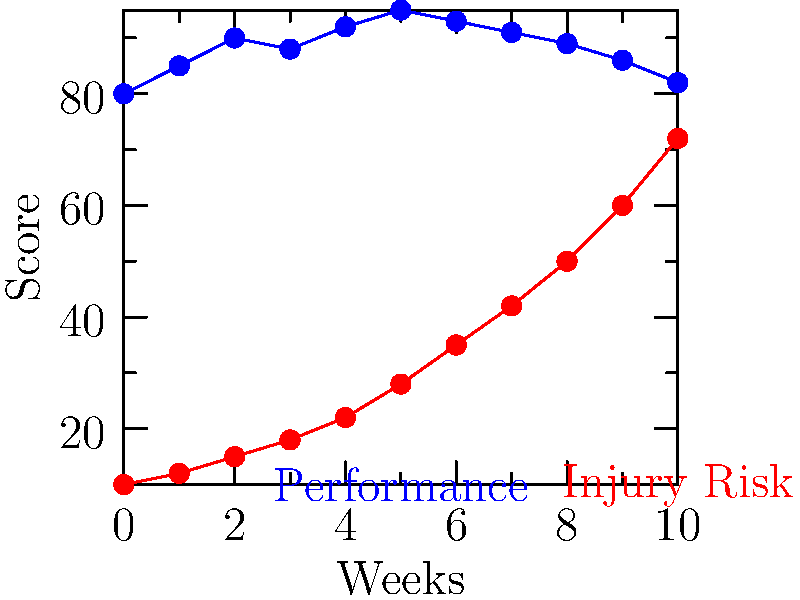Based on the graph showing a player's performance metrics (blue) and injury risk (red) over 10 weeks, at which point should you consider resting the player to prevent potential injury? To determine when to rest the player, we need to analyze the relationship between performance and injury risk:

1. Observe the performance trend (blue line):
   - Weeks 0-5: Performance improves from 80 to 95
   - Weeks 5-10: Performance declines from 95 to 82

2. Analyze the injury risk trend (red line):
   - Consistently increasing from week 0 to 10
   - Steeper increase after week 5

3. Identify the critical point:
   - Week 5 marks the peak performance (95)
   - After week 5, performance declines while injury risk continues to rise sharply

4. Consider the risk-reward balance:
   - Before week 5: Performance gains outweigh the increasing injury risk
   - After week 5: Declining performance coupled with rapidly increasing injury risk

5. Make a decision:
   - Optimal time to rest the player is at week 5
   - This allows maximum performance benefit while minimizing injury risk

6. Machine learning implication:
   - This pattern could be used to train a model to predict optimal rest periods for players based on similar performance and injury risk curves
Answer: Week 5 